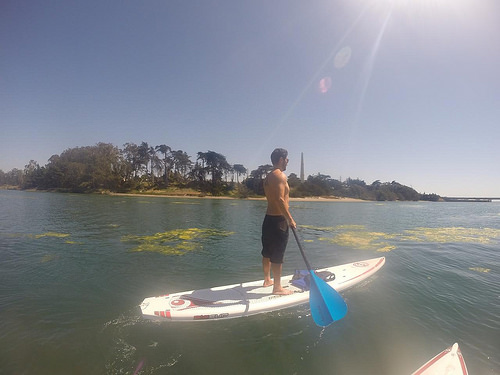<image>
Is there a man above the water? Yes. The man is positioned above the water in the vertical space, higher up in the scene. Is there a man above the lake? No. The man is not positioned above the lake. The vertical arrangement shows a different relationship. 